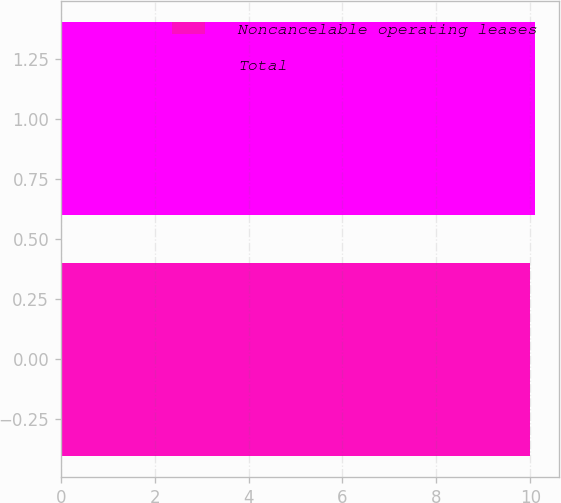Convert chart to OTSL. <chart><loc_0><loc_0><loc_500><loc_500><bar_chart><fcel>Noncancelable operating leases<fcel>Total<nl><fcel>10<fcel>10.1<nl></chart> 